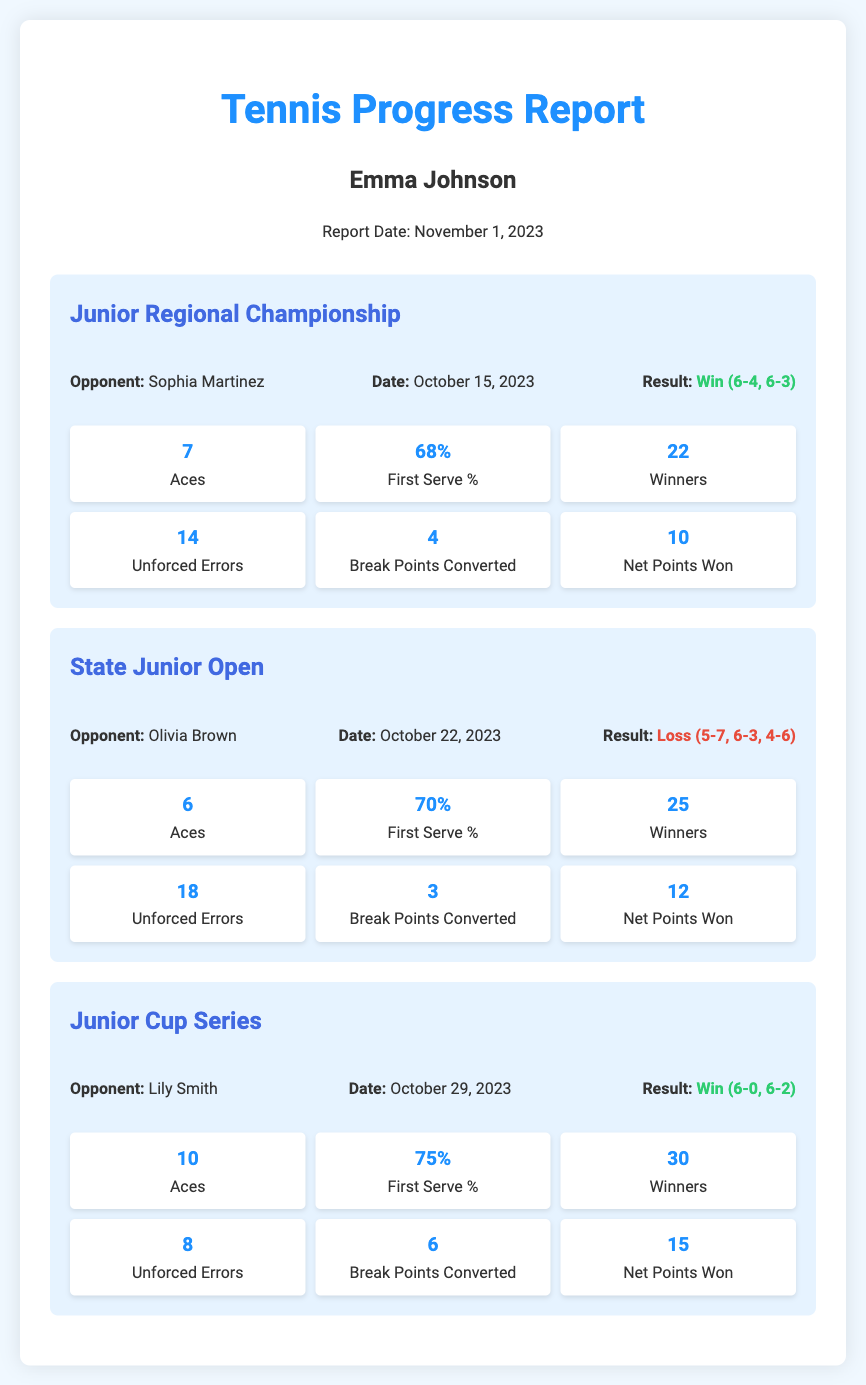what is the name of the player? The player's name is mentioned at the top of the report, presented as "Emma Johnson."
Answer: Emma Johnson what was the result of the Junior Regional Championship? The result of the match is specified as "Win (6-4, 6-3)."
Answer: Win (6-4, 6-3) how many aces did Emma serve in the State Junior Open? The document provides the number of aces served in that match as "6."
Answer: 6 what percentage of first serves did Emma make in the Junior Cup Series? The first serve percentage for that match is indicated as "75%."
Answer: 75% who was Emma's opponent in the Junior Regional Championship? The opponent's name is listed in the match details section as "Sophia Martinez."
Answer: Sophia Martinez how many unforced errors did Emma make in the Junior Cup Series? The number of unforced errors for this match is recorded as "8."
Answer: 8 which match had the highest number of winners? By comparing the winners across matches, the Junior Cup Series had the highest count of "30" winners.
Answer: Junior Cup Series how many break points did Emma convert in the State Junior Open? The conversion count of break points is provided as "3."
Answer: 3 what was the date of the match against Lily Smith? The match date is mentioned under the match details as "October 29, 2023."
Answer: October 29, 2023 